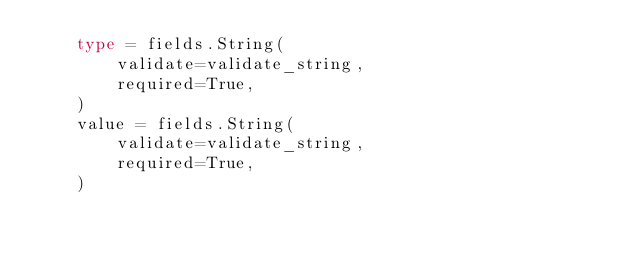Convert code to text. <code><loc_0><loc_0><loc_500><loc_500><_Python_>    type = fields.String(
        validate=validate_string,
        required=True,
    )
    value = fields.String(
        validate=validate_string,
        required=True,
    )
</code> 